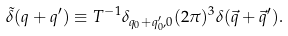<formula> <loc_0><loc_0><loc_500><loc_500>\tilde { \delta } ( q + q ^ { \prime } ) \equiv T ^ { - 1 } \delta _ { q _ { 0 } + q ^ { \prime } _ { 0 } , 0 } ( 2 \pi ) ^ { 3 } \delta ( \vec { q } + \vec { q } ^ { \prime } ) .</formula> 